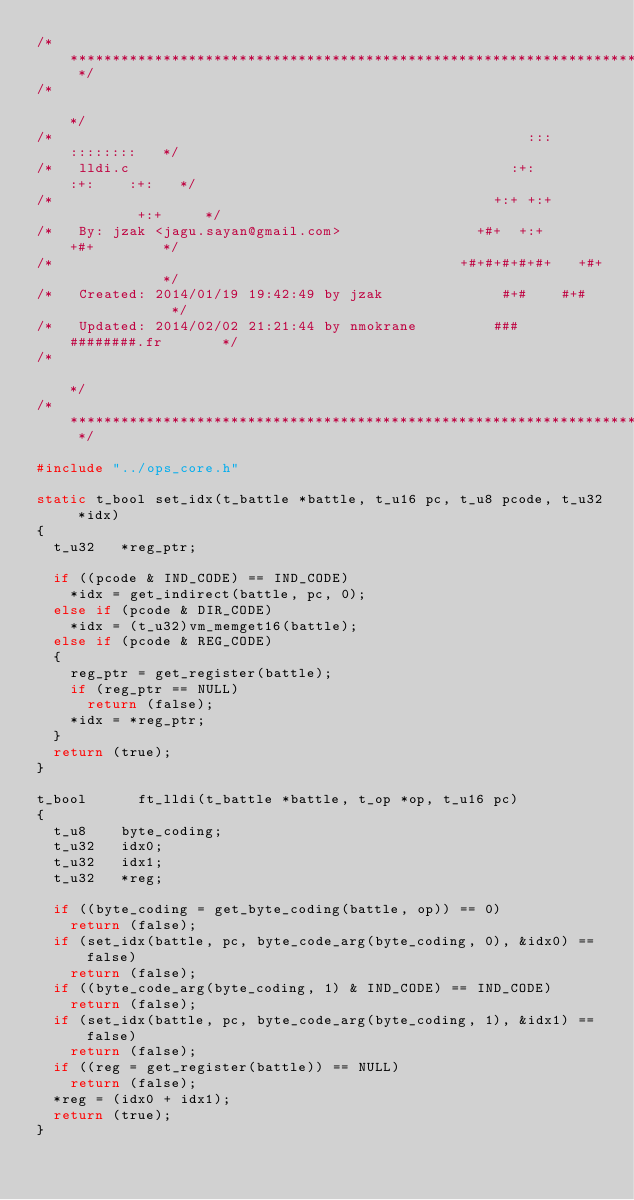<code> <loc_0><loc_0><loc_500><loc_500><_C_>/* ************************************************************************** */
/*                                                                            */
/*                                                        :::      ::::::::   */
/*   lldi.c                                             :+:      :+:    :+:   */
/*                                                    +:+ +:+         +:+     */
/*   By: jzak <jagu.sayan@gmail.com>                +#+  +:+       +#+        */
/*                                                +#+#+#+#+#+   +#+           */
/*   Created: 2014/01/19 19:42:49 by jzak              #+#    #+#             */
/*   Updated: 2014/02/02 21:21:44 by nmokrane         ###   ########.fr       */
/*                                                                            */
/* ************************************************************************** */

#include "../ops_core.h"

static t_bool	set_idx(t_battle *battle, t_u16 pc, t_u8 pcode, t_u32 *idx)
{
	t_u32		*reg_ptr;

	if ((pcode & IND_CODE) == IND_CODE)
		*idx = get_indirect(battle, pc, 0);
	else if (pcode & DIR_CODE)
		*idx = (t_u32)vm_memget16(battle);
	else if (pcode & REG_CODE)
	{
		reg_ptr = get_register(battle);
		if (reg_ptr == NULL)
			return (false);
		*idx = *reg_ptr;
	}
	return (true);
}

t_bool			ft_lldi(t_battle *battle, t_op *op, t_u16 pc)
{
	t_u8		byte_coding;
	t_u32		idx0;
	t_u32		idx1;
	t_u32		*reg;

	if ((byte_coding = get_byte_coding(battle, op)) == 0)
		return (false);
	if (set_idx(battle, pc, byte_code_arg(byte_coding, 0), &idx0) == false)
		return (false);
	if ((byte_code_arg(byte_coding, 1) & IND_CODE) == IND_CODE)
		return (false);
	if (set_idx(battle, pc, byte_code_arg(byte_coding, 1), &idx1) == false)
		return (false);
	if ((reg = get_register(battle)) == NULL)
		return (false);
	*reg = (idx0 + idx1);
	return (true);
}
</code> 